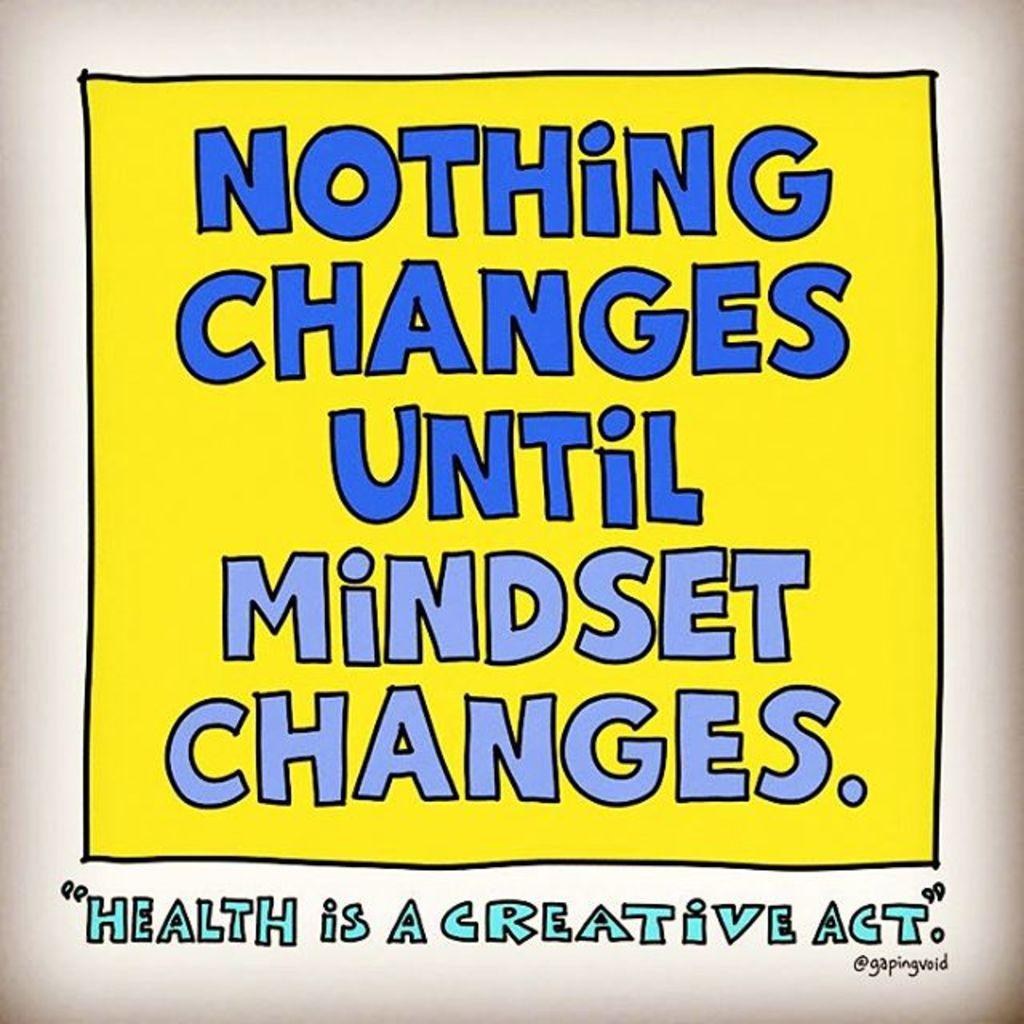What is the main object in the center of the image? There is a paper in the center of the image. What is written on the paper? The phrase "Nothing Changes Until Mindset Changes" is written on the paper. What type of magic trick is being performed with the paper in the image? There is no magic trick being performed in the image; it simply shows a paper with a phrase written on it. 